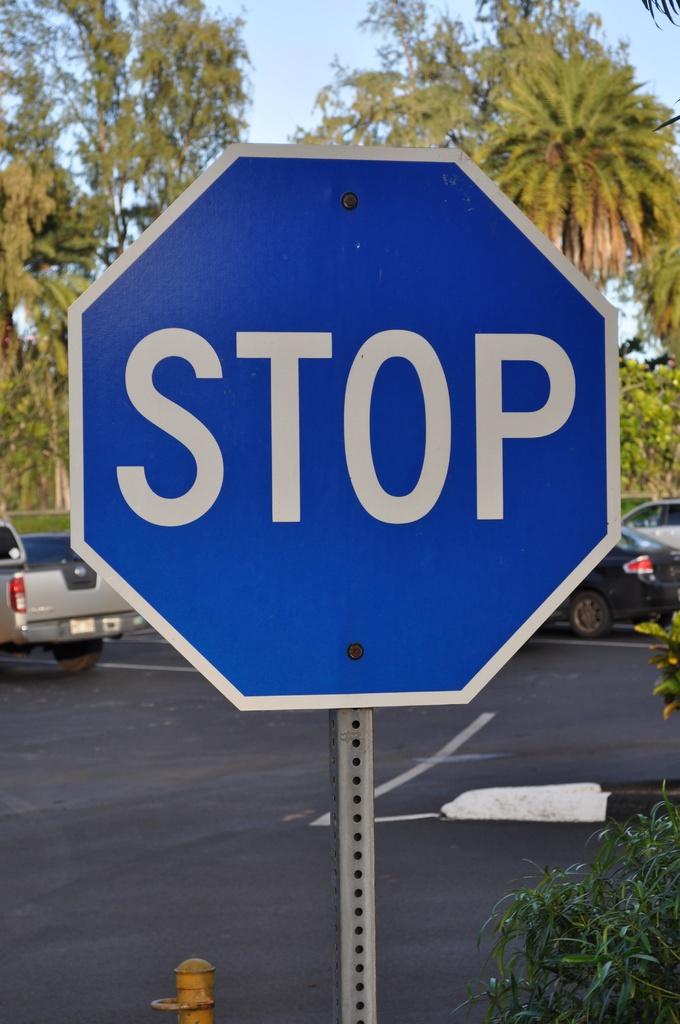What sign is this?
Provide a succinct answer. Stop. 